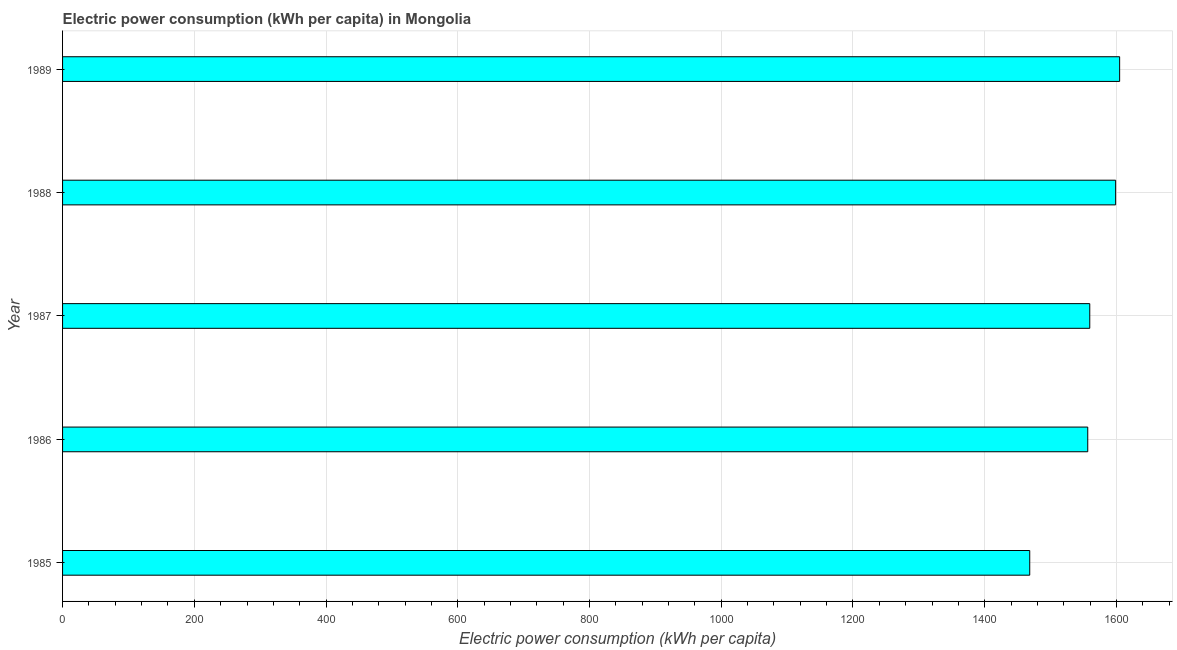Does the graph contain any zero values?
Your response must be concise. No. What is the title of the graph?
Make the answer very short. Electric power consumption (kWh per capita) in Mongolia. What is the label or title of the X-axis?
Provide a succinct answer. Electric power consumption (kWh per capita). What is the electric power consumption in 1985?
Offer a very short reply. 1468.35. Across all years, what is the maximum electric power consumption?
Keep it short and to the point. 1604.85. Across all years, what is the minimum electric power consumption?
Your answer should be compact. 1468.35. What is the sum of the electric power consumption?
Your answer should be compact. 7787.92. What is the difference between the electric power consumption in 1986 and 1987?
Offer a terse response. -3.06. What is the average electric power consumption per year?
Ensure brevity in your answer.  1557.58. What is the median electric power consumption?
Offer a very short reply. 1559.5. In how many years, is the electric power consumption greater than 1160 kWh per capita?
Provide a succinct answer. 5. Do a majority of the years between 1988 and 1989 (inclusive) have electric power consumption greater than 1440 kWh per capita?
Your answer should be compact. Yes. What is the ratio of the electric power consumption in 1985 to that in 1988?
Make the answer very short. 0.92. Is the difference between the electric power consumption in 1985 and 1986 greater than the difference between any two years?
Your answer should be compact. No. What is the difference between the highest and the second highest electric power consumption?
Your answer should be very brief. 6.07. Is the sum of the electric power consumption in 1985 and 1986 greater than the maximum electric power consumption across all years?
Provide a succinct answer. Yes. What is the difference between the highest and the lowest electric power consumption?
Offer a very short reply. 136.5. In how many years, is the electric power consumption greater than the average electric power consumption taken over all years?
Your response must be concise. 3. Are all the bars in the graph horizontal?
Provide a succinct answer. Yes. What is the difference between two consecutive major ticks on the X-axis?
Offer a terse response. 200. What is the Electric power consumption (kWh per capita) of 1985?
Make the answer very short. 1468.35. What is the Electric power consumption (kWh per capita) in 1986?
Give a very brief answer. 1556.44. What is the Electric power consumption (kWh per capita) in 1987?
Ensure brevity in your answer.  1559.5. What is the Electric power consumption (kWh per capita) of 1988?
Provide a short and direct response. 1598.78. What is the Electric power consumption (kWh per capita) of 1989?
Offer a very short reply. 1604.85. What is the difference between the Electric power consumption (kWh per capita) in 1985 and 1986?
Keep it short and to the point. -88.09. What is the difference between the Electric power consumption (kWh per capita) in 1985 and 1987?
Give a very brief answer. -91.15. What is the difference between the Electric power consumption (kWh per capita) in 1985 and 1988?
Give a very brief answer. -130.43. What is the difference between the Electric power consumption (kWh per capita) in 1985 and 1989?
Your response must be concise. -136.5. What is the difference between the Electric power consumption (kWh per capita) in 1986 and 1987?
Keep it short and to the point. -3.06. What is the difference between the Electric power consumption (kWh per capita) in 1986 and 1988?
Your answer should be very brief. -42.35. What is the difference between the Electric power consumption (kWh per capita) in 1986 and 1989?
Offer a terse response. -48.42. What is the difference between the Electric power consumption (kWh per capita) in 1987 and 1988?
Ensure brevity in your answer.  -39.28. What is the difference between the Electric power consumption (kWh per capita) in 1987 and 1989?
Your answer should be very brief. -45.35. What is the difference between the Electric power consumption (kWh per capita) in 1988 and 1989?
Ensure brevity in your answer.  -6.07. What is the ratio of the Electric power consumption (kWh per capita) in 1985 to that in 1986?
Give a very brief answer. 0.94. What is the ratio of the Electric power consumption (kWh per capita) in 1985 to that in 1987?
Make the answer very short. 0.94. What is the ratio of the Electric power consumption (kWh per capita) in 1985 to that in 1988?
Give a very brief answer. 0.92. What is the ratio of the Electric power consumption (kWh per capita) in 1985 to that in 1989?
Provide a short and direct response. 0.92. What is the ratio of the Electric power consumption (kWh per capita) in 1986 to that in 1987?
Your answer should be compact. 1. What is the ratio of the Electric power consumption (kWh per capita) in 1986 to that in 1989?
Offer a terse response. 0.97. What is the ratio of the Electric power consumption (kWh per capita) in 1988 to that in 1989?
Your response must be concise. 1. 